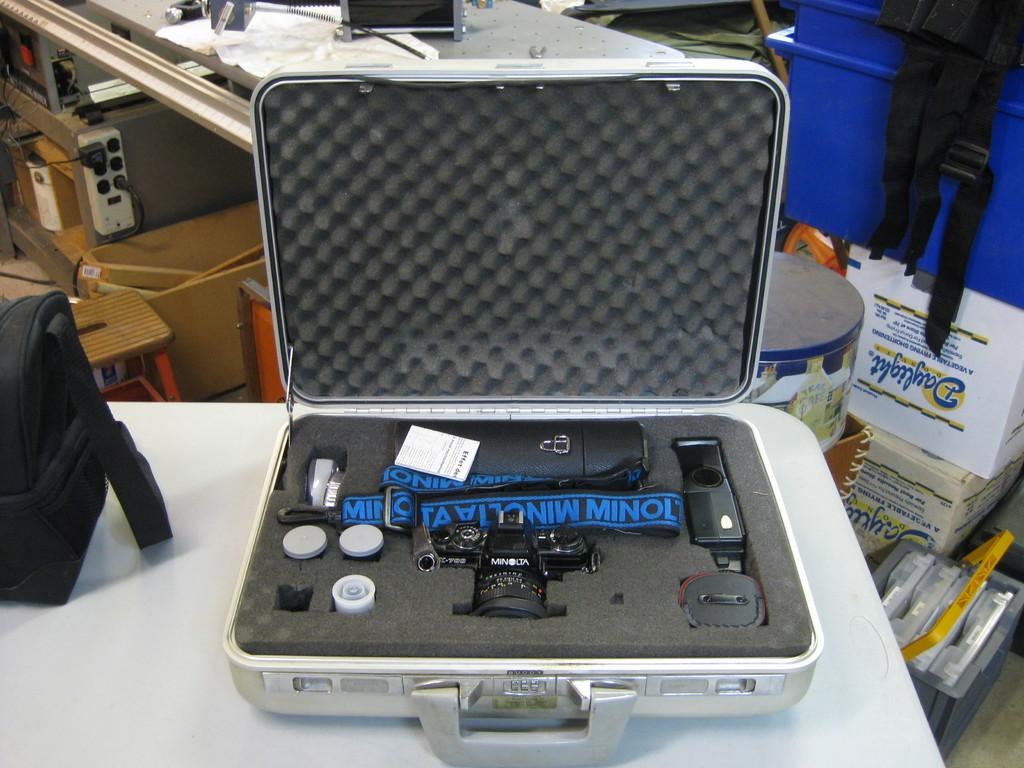What object is present in the image that people might use for traveling? There is a suitcase in the image that people might use for traveling. What is inside the suitcase? The suitcase contains a camera and camera accessories. Where is the suitcase located in the image? The suitcase is placed on a table. What type of plants can be seen growing in the suitcase? There are no plants visible in the suitcase; it contains a camera and camera accessories. 